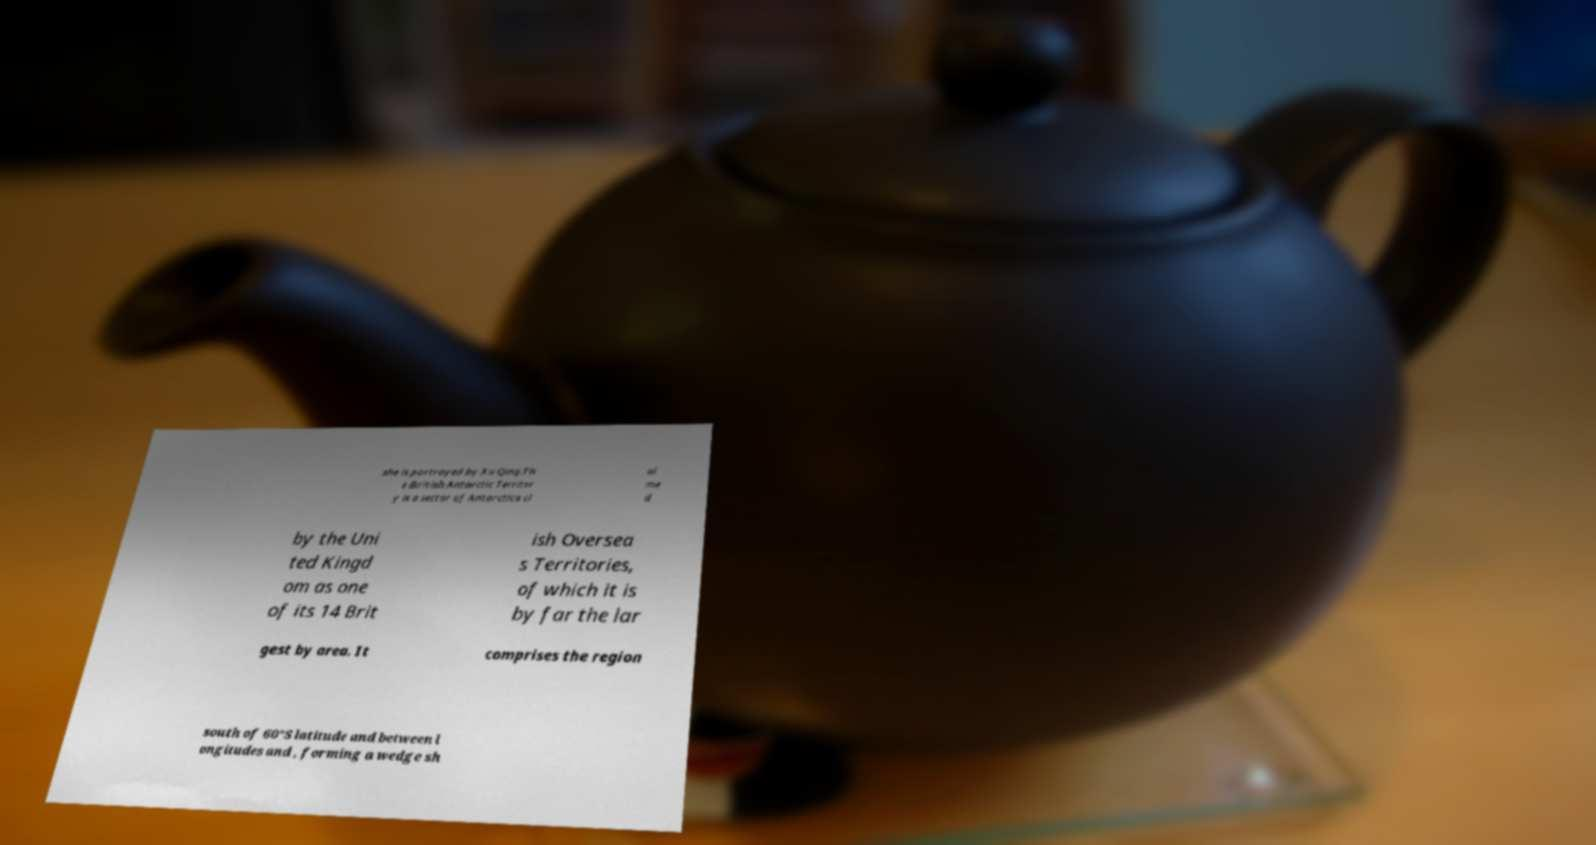Could you assist in decoding the text presented in this image and type it out clearly? she is portrayed by Xu Qing.Th e British Antarctic Territor y is a sector of Antarctica cl ai me d by the Uni ted Kingd om as one of its 14 Brit ish Oversea s Territories, of which it is by far the lar gest by area. It comprises the region south of 60°S latitude and between l ongitudes and , forming a wedge sh 